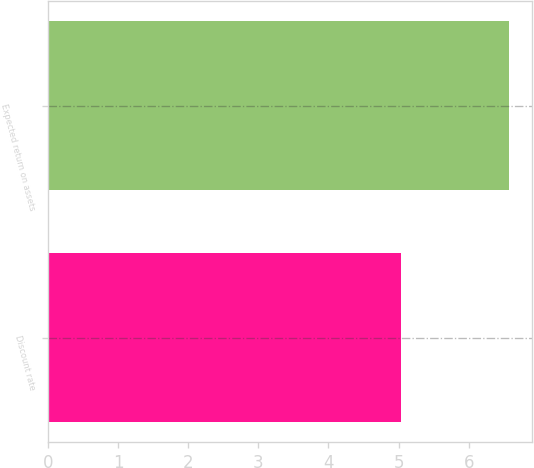<chart> <loc_0><loc_0><loc_500><loc_500><bar_chart><fcel>Discount rate<fcel>Expected return on assets<nl><fcel>5.04<fcel>6.58<nl></chart> 